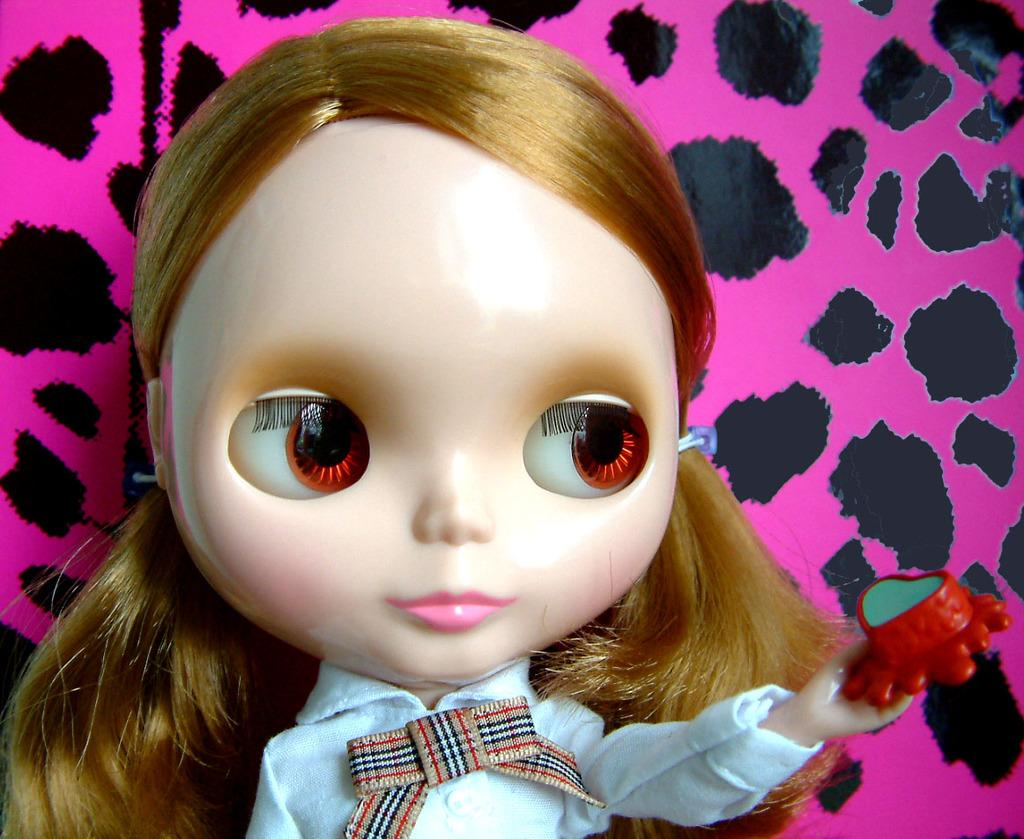What is the main subject of the picture? The main subject of the picture is a toy of a girl. What can be seen in the background of the image? There are colorful things visible in the background of the image. What type of silk is being used to create the toy in the image? There is no mention of silk or any fabric used in the toy's creation in the image. Is there a turkey visible in the image? No, there is no turkey present in the image. 